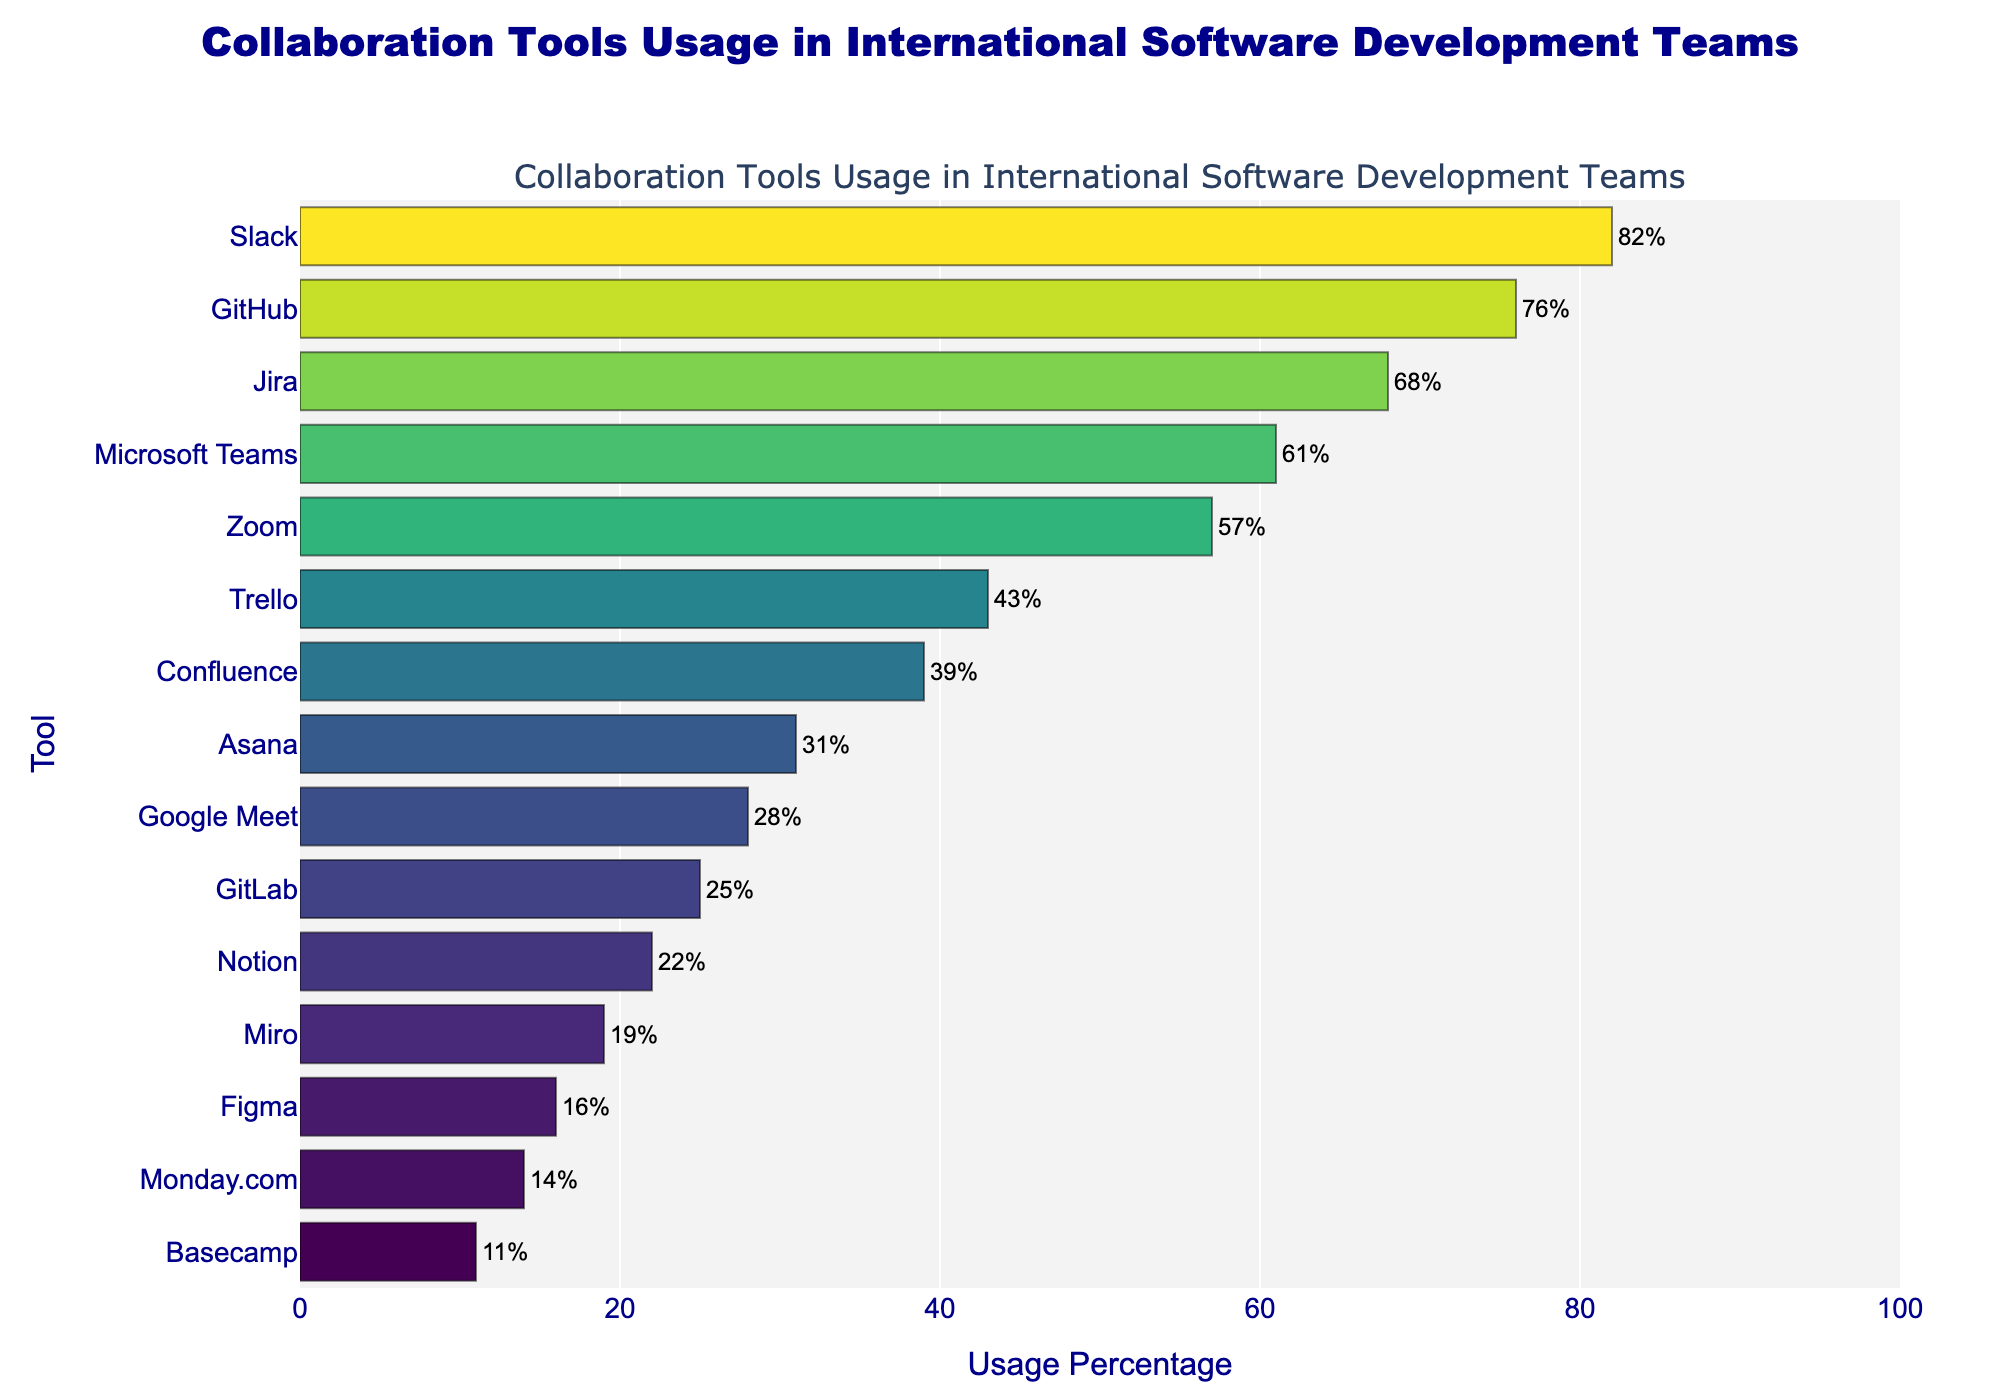What is the usage percentage of Slack? Slack's bar is positioned at the top of the plot and labeled with its usage percentage. The bar reaches up to 82% on the x-axis.
Answer: 82% Which tool has a higher usage percentage, Trello or Google Meet? Compare the bars for Trello and Google Meet. Trello's bar is longer and labeled 43%, while Google Meet's bar is shorter and labeled 28%.
Answer: Trello How much higher is the usage percentage of Jira compared to Asana? Jira's usage percentage is 68%, and Asana's is 31%. Calculate the difference: 68% - 31% = 37%.
Answer: 37% Arrange the top three tools by usage percentage. The top three tools have the longest bars starting from top to bottom: Slack, GitHub, and Jira. Their usage percentages are 82%, 76%, and 68%, respectively.
Answer: Slack, GitHub, Jira Which tools have a usage percentage less than 20%? Identify the bars below the 20% mark on the x-axis: Miro (19%), Figma (16%), Monday.com (14%), and Basecamp (11%).
Answer: Miro, Figma, Monday.com, Basecamp What is the difference in usage percentage between Microsoft Teams and Zoom? The usage percentage for Microsoft Teams is 61%, and for Zoom, it is 57%. Calculate the difference: 61% - 57% = 4%.
Answer: 4% What color is used to represent the bar for Asana? Identify Asana's bar and look at the color gradient. Asana's bar, which represents 31%, appears in a yellowish shade on the Viridis color scale.
Answer: Yellowish List the tools with a usage percentage between 20% and 40%. Identify the bars that fall within this range on the x-axis: Confluence (39%), Asana (31%), Google Meet (28%), and GitLab (25%), Notion (22%).
Answer: Confluence, Asana, Google Meet, GitLab, Notion How many tools have a usage percentage greater than or equal to 50%? Count the bars that extend to the 50% mark or beyond: Slack, GitHub, Jira, Microsoft Teams, and Zoom.
Answer: 5 What is the average usage percentage of the tools ranked 4th and 5th? The 4th and 5th ranked tools are Microsoft Teams (61%) and Zoom (57%). Calculate the average: (61% + 57%) / 2 = 59%.
Answer: 59% 